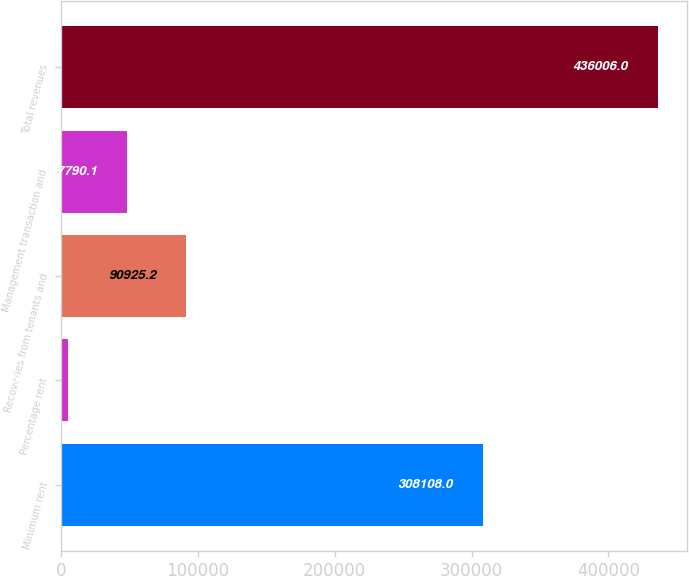<chart> <loc_0><loc_0><loc_500><loc_500><bar_chart><fcel>Minimum rent<fcel>Percentage rent<fcel>Recoveries from tenants and<fcel>Management transaction and<fcel>Total revenues<nl><fcel>308108<fcel>4655<fcel>90925.2<fcel>47790.1<fcel>436006<nl></chart> 